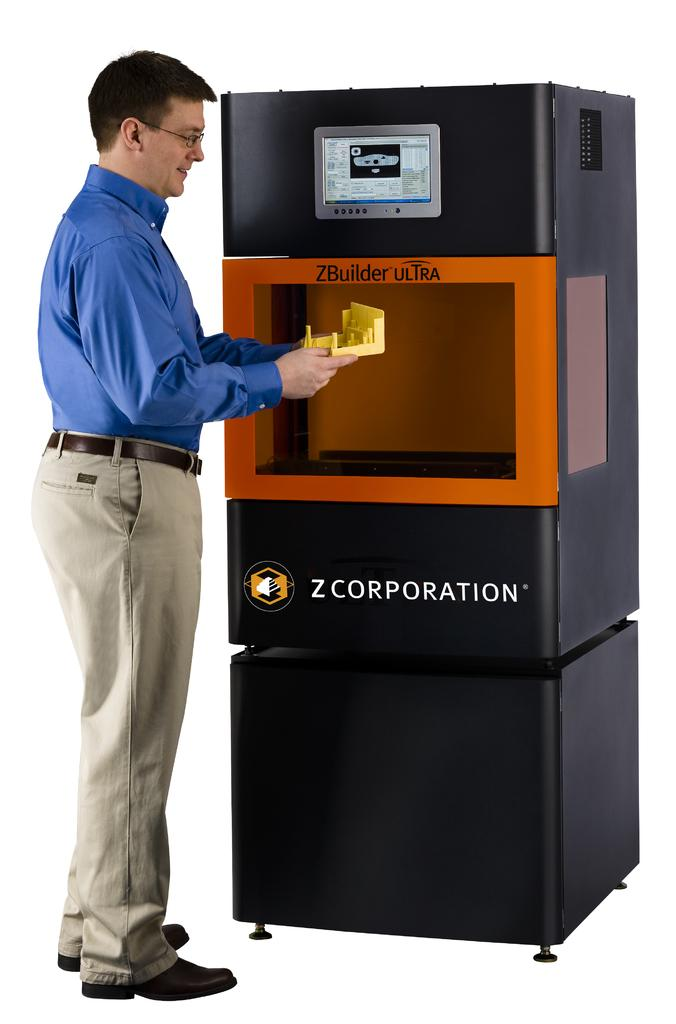<image>
Write a terse but informative summary of the picture. Man with a blue shirt is standing in front of a ZBuilder Ultra 